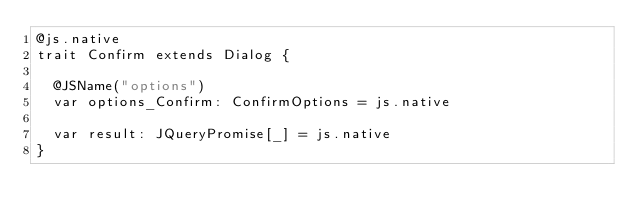Convert code to text. <code><loc_0><loc_0><loc_500><loc_500><_Scala_>@js.native
trait Confirm extends Dialog {
  
  @JSName("options")
  var options_Confirm: ConfirmOptions = js.native
  
  var result: JQueryPromise[_] = js.native
}
</code> 